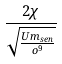Convert formula to latex. <formula><loc_0><loc_0><loc_500><loc_500>\frac { 2 \chi } { \sqrt { \frac { U m _ { s e n } } { o ^ { 9 } } } }</formula> 